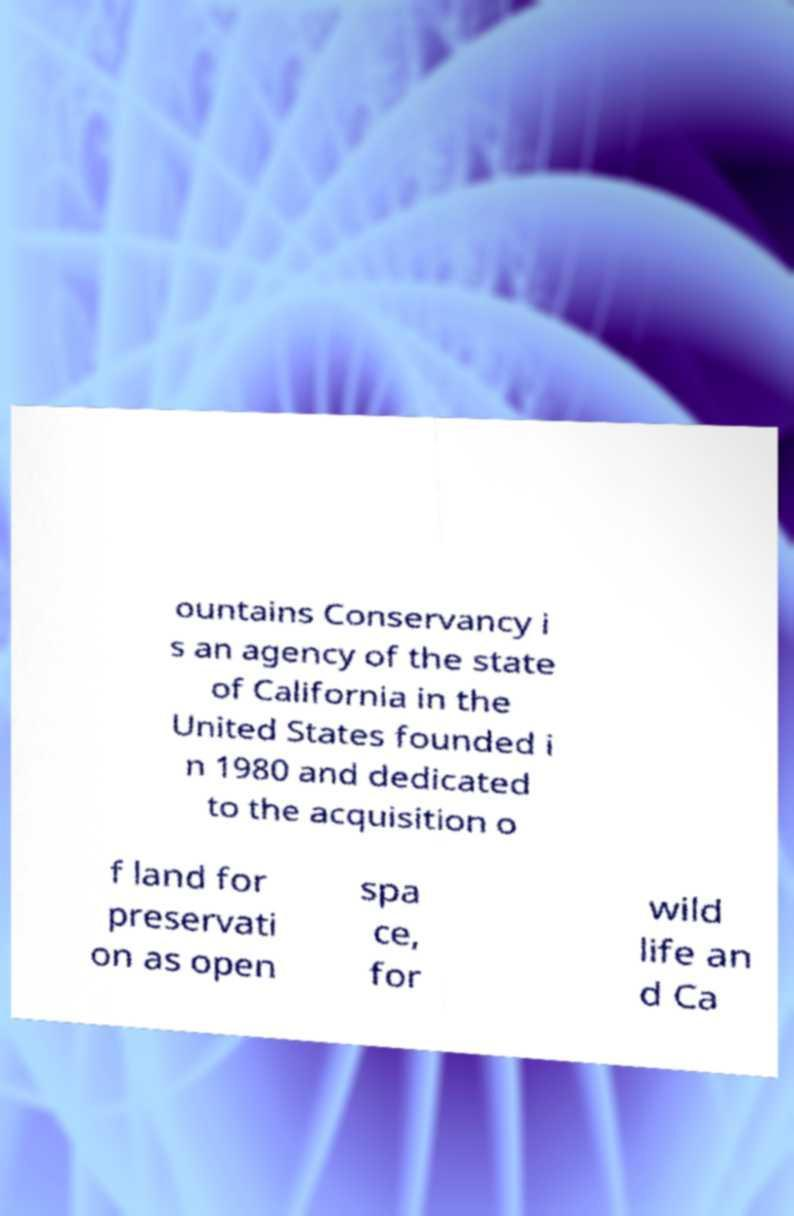I need the written content from this picture converted into text. Can you do that? ountains Conservancy i s an agency of the state of California in the United States founded i n 1980 and dedicated to the acquisition o f land for preservati on as open spa ce, for wild life an d Ca 